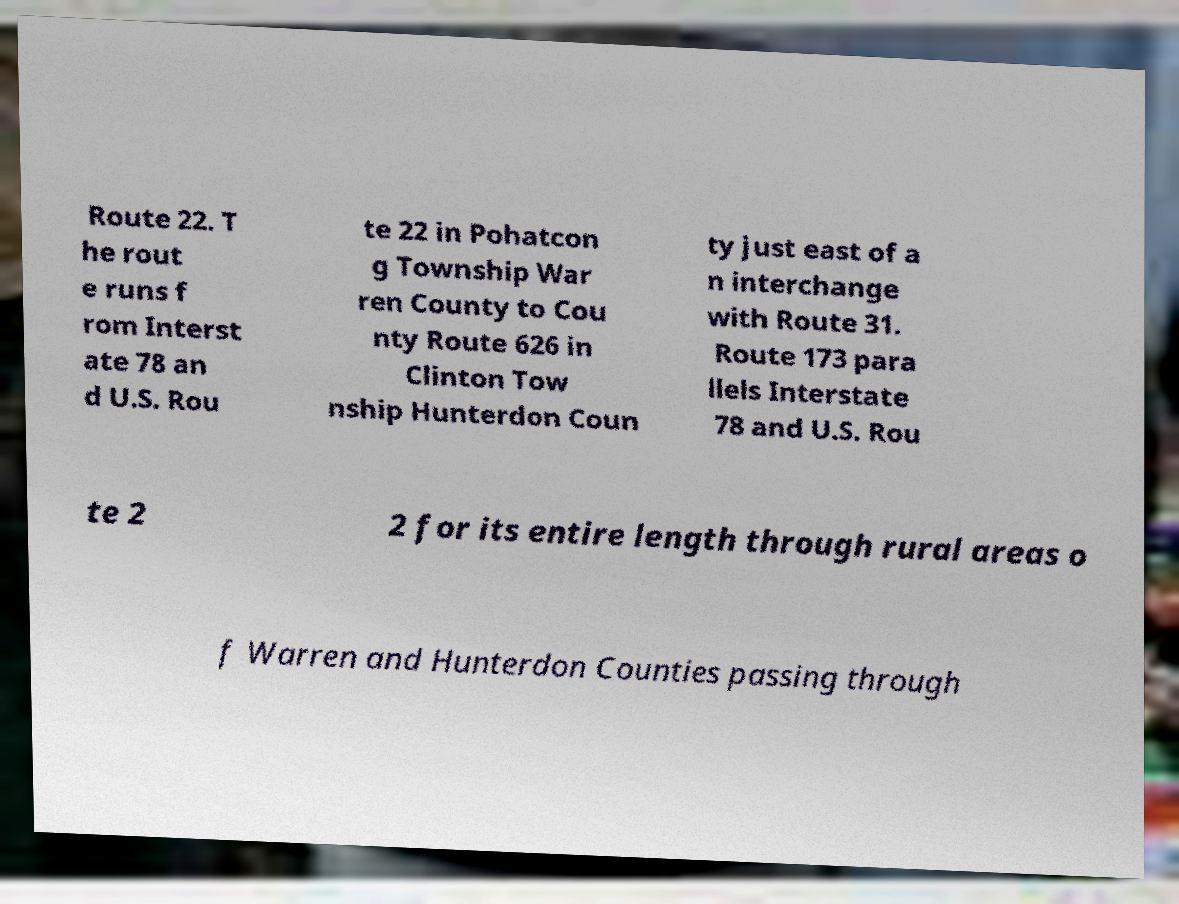There's text embedded in this image that I need extracted. Can you transcribe it verbatim? Route 22. T he rout e runs f rom Interst ate 78 an d U.S. Rou te 22 in Pohatcon g Township War ren County to Cou nty Route 626 in Clinton Tow nship Hunterdon Coun ty just east of a n interchange with Route 31. Route 173 para llels Interstate 78 and U.S. Rou te 2 2 for its entire length through rural areas o f Warren and Hunterdon Counties passing through 